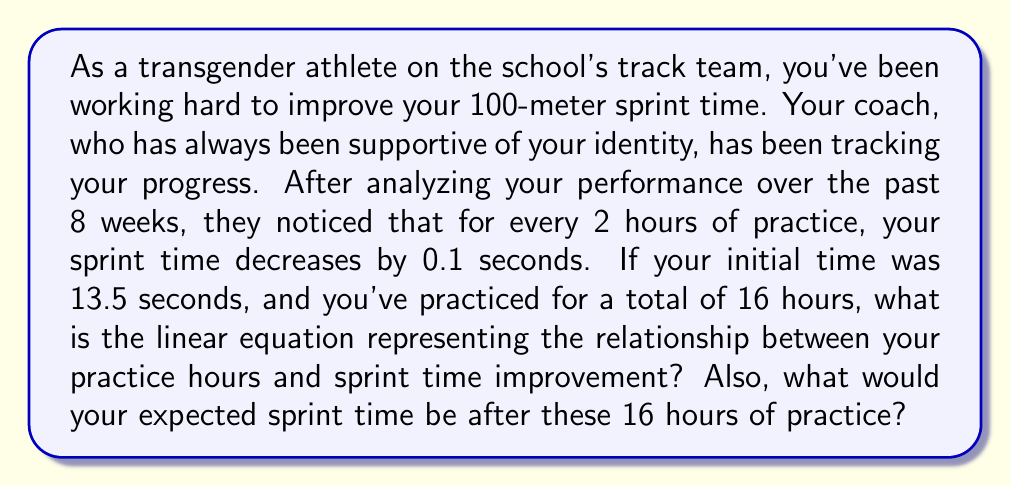Provide a solution to this math problem. Let's approach this step-by-step:

1) First, we need to identify the variables:
   Let $x$ = number of practice hours
   Let $y$ = sprint time in seconds

2) We're told that for every 2 hours of practice, the sprint time decreases by 0.1 seconds. This gives us the rate of change:

   $\frac{\text{Change in y}}{\text{Change in x}} = \frac{-0.1}{2} = -0.05$

   This means that for every 1 hour of practice, the sprint time decreases by 0.05 seconds.

3) The slope of our line will be -0.05. In the standard form of a linear equation $y = mx + b$, $m = -0.05$.

4) We're given the initial time (y-intercept) of 13.5 seconds. This is our $b$ value.

5) Therefore, our linear equation is:

   $y = -0.05x + 13.5$

6) To find the expected sprint time after 16 hours of practice, we substitute $x = 16$ into our equation:

   $y = -0.05(16) + 13.5$
   $y = -0.8 + 13.5$
   $y = 12.7$

Therefore, after 16 hours of practice, the expected sprint time would be 12.7 seconds.
Answer: The linear equation is $y = -0.05x + 13.5$, where $x$ is the number of practice hours and $y$ is the sprint time in seconds. The expected sprint time after 16 hours of practice is 12.7 seconds. 